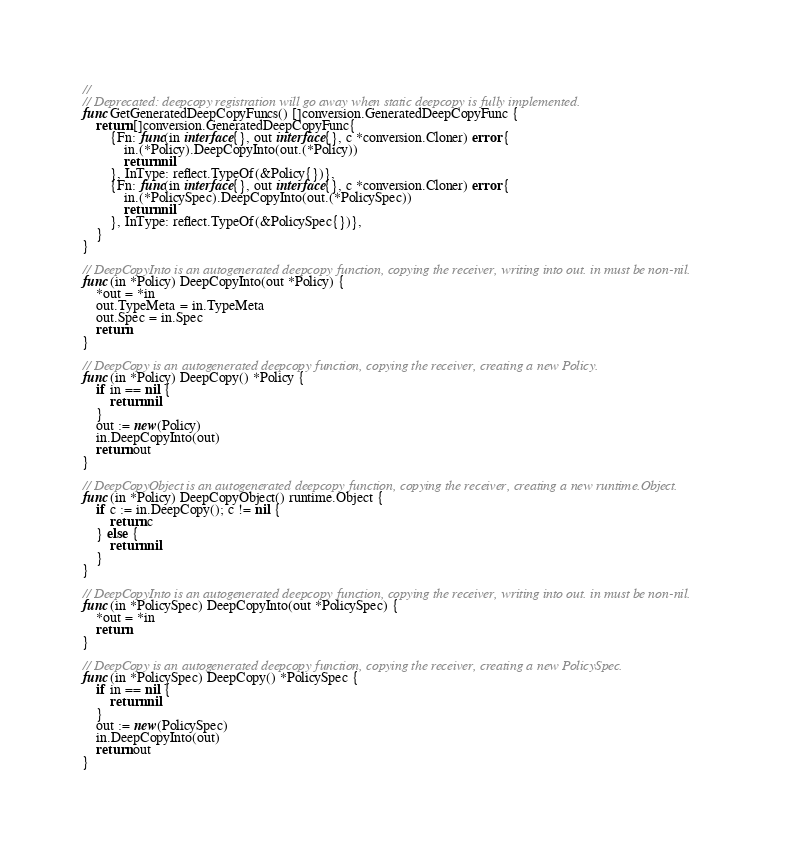<code> <loc_0><loc_0><loc_500><loc_500><_Go_>//
// Deprecated: deepcopy registration will go away when static deepcopy is fully implemented.
func GetGeneratedDeepCopyFuncs() []conversion.GeneratedDeepCopyFunc {
	return []conversion.GeneratedDeepCopyFunc{
		{Fn: func(in interface{}, out interface{}, c *conversion.Cloner) error {
			in.(*Policy).DeepCopyInto(out.(*Policy))
			return nil
		}, InType: reflect.TypeOf(&Policy{})},
		{Fn: func(in interface{}, out interface{}, c *conversion.Cloner) error {
			in.(*PolicySpec).DeepCopyInto(out.(*PolicySpec))
			return nil
		}, InType: reflect.TypeOf(&PolicySpec{})},
	}
}

// DeepCopyInto is an autogenerated deepcopy function, copying the receiver, writing into out. in must be non-nil.
func (in *Policy) DeepCopyInto(out *Policy) {
	*out = *in
	out.TypeMeta = in.TypeMeta
	out.Spec = in.Spec
	return
}

// DeepCopy is an autogenerated deepcopy function, copying the receiver, creating a new Policy.
func (in *Policy) DeepCopy() *Policy {
	if in == nil {
		return nil
	}
	out := new(Policy)
	in.DeepCopyInto(out)
	return out
}

// DeepCopyObject is an autogenerated deepcopy function, copying the receiver, creating a new runtime.Object.
func (in *Policy) DeepCopyObject() runtime.Object {
	if c := in.DeepCopy(); c != nil {
		return c
	} else {
		return nil
	}
}

// DeepCopyInto is an autogenerated deepcopy function, copying the receiver, writing into out. in must be non-nil.
func (in *PolicySpec) DeepCopyInto(out *PolicySpec) {
	*out = *in
	return
}

// DeepCopy is an autogenerated deepcopy function, copying the receiver, creating a new PolicySpec.
func (in *PolicySpec) DeepCopy() *PolicySpec {
	if in == nil {
		return nil
	}
	out := new(PolicySpec)
	in.DeepCopyInto(out)
	return out
}
</code> 